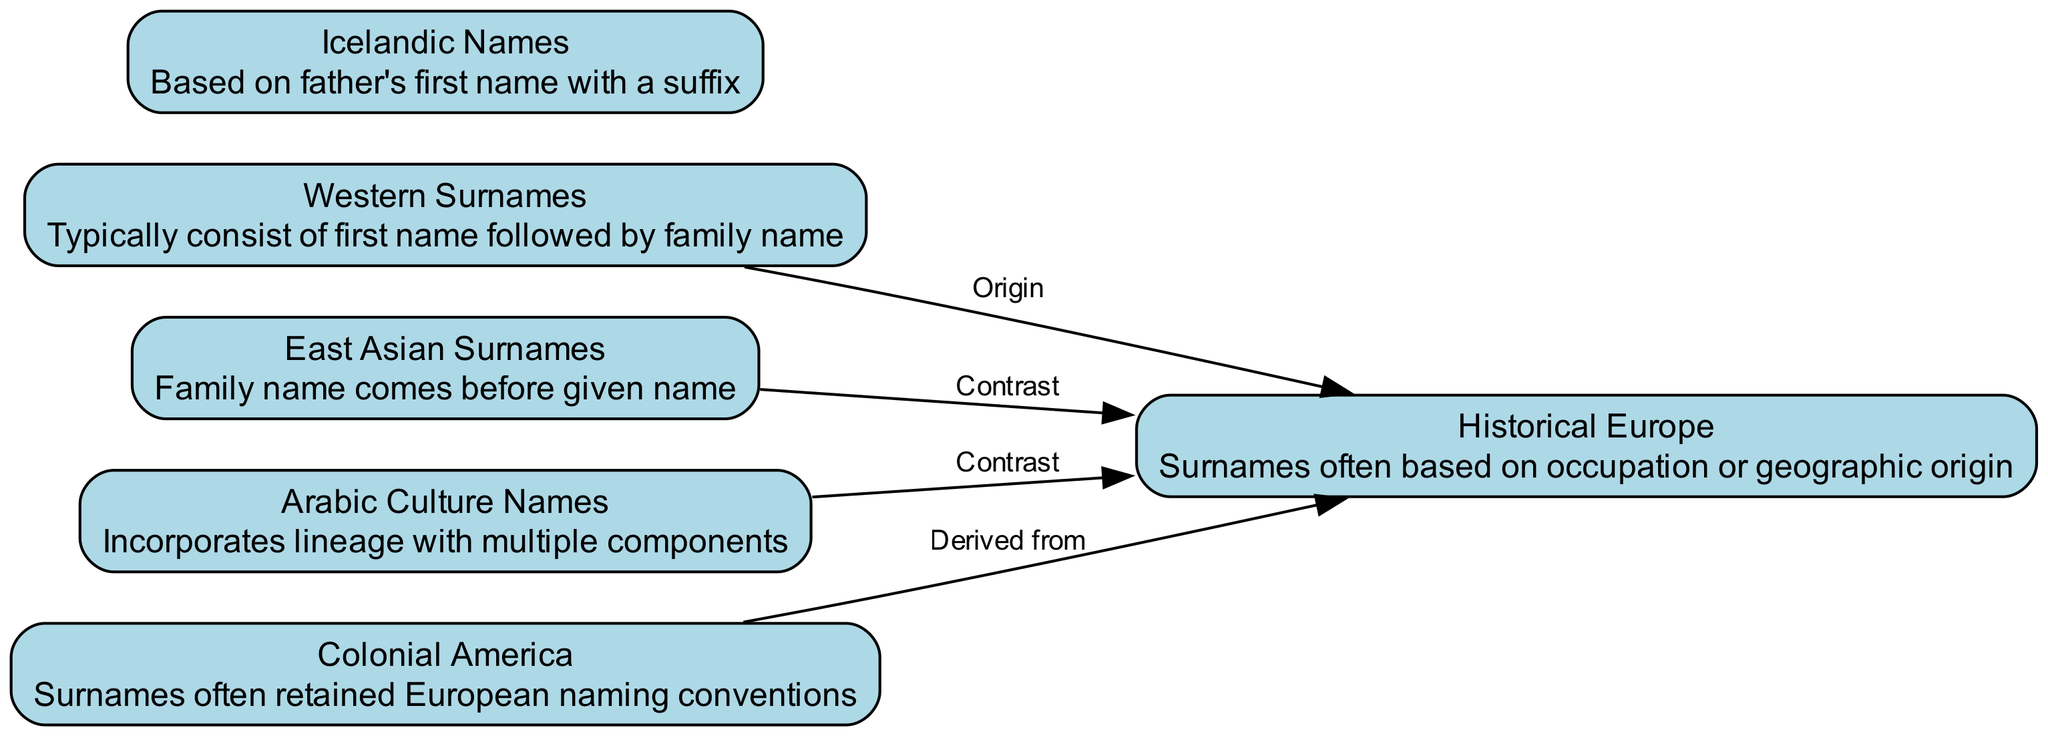What are the two main components involved in the naming conventions of Western surnames? The diagram shows that Western surnames involve a first name followed by a family name, which are the two main components described.
Answer: first name, family name How many nodes are present in this diagram? By counting all the distinct categories of naming conventions in the diagram, we find there are six nodes represented.
Answer: 6 What is the relationship between Western surnames and Historical Europe? The diagram indicates that Western surnames have an 'Origin' relationship with Historical Europe, showing they are rooted in that context.
Answer: Origin Which naming convention places the family name before the given name? The diagram highlights that East Asian surnames exhibit this unique feature where the family name comes before the given name.
Answer: East Asian Surnames What is the key feature of Arabic culture names as seen in the diagram? According to the diagram, Arabic culture names incorporate lineage with multiple components, showcasing their complexity.
Answer: Incorporates lineage with multiple components How do Colonial American surnames relate to Historical Europe? The diagram shows a direct relationship labeled 'Derived from,' indicating Colonial American surnames are based on Historical European naming conventions.
Answer: Derived from What type of comparison is made between Icelandic names and another concept in the diagram? The diagram indicates a comparison relationship between Icelandic names and their derived attributes from a father's first name, highlighting the lineage aspect.
Answer: Comparison What naming convention contrasts significantly with Historical Europe as per the diagram? The diagram marks East Asian and Arabic culture names as contrasting to Historical Europe, suggesting different foundational elements in their naming systems.
Answer: East Asian Surnames, Arabic Culture Names What specific suffixes are used in Icelandic naming conventions that differentiate them? Though the diagram does not explicitly mention suffixes, it implies that Icelandic names are based on father’s first name with a suffix, indicating tradition and lineage.
Answer: Father's first name with a suffix 